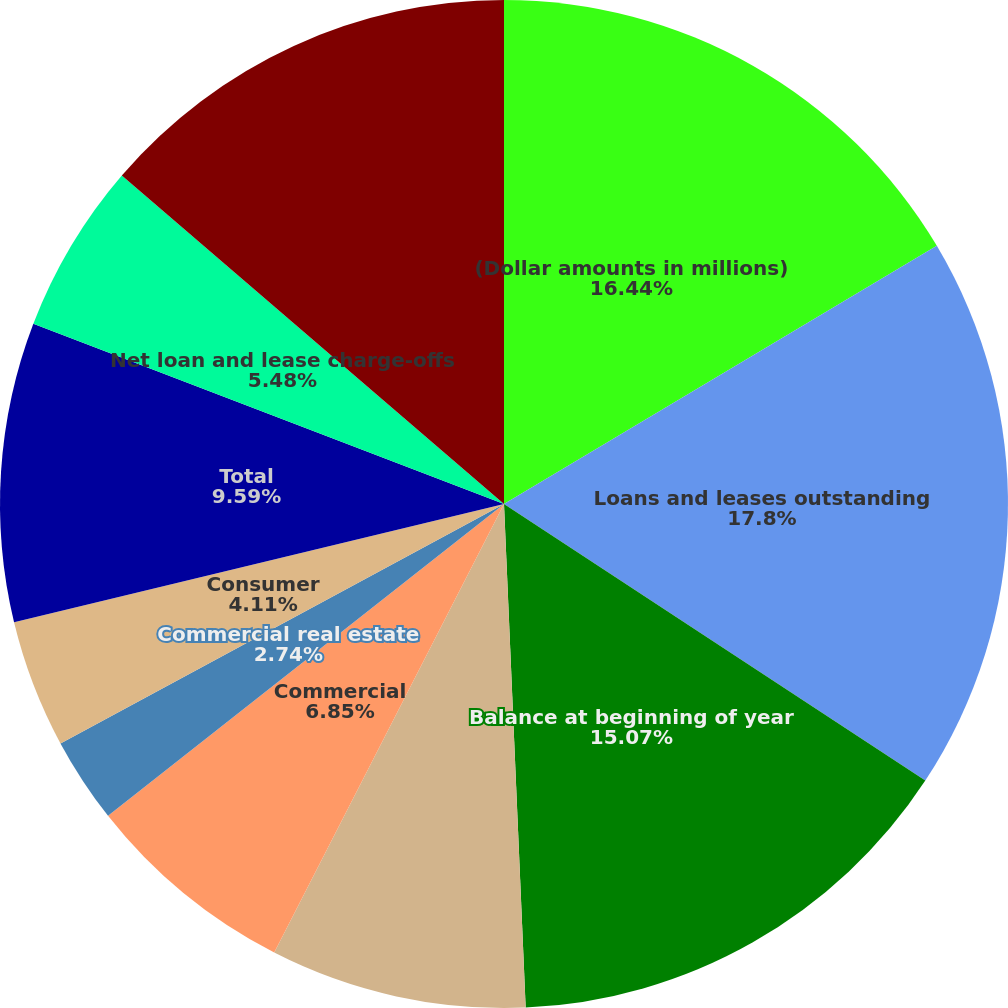Convert chart. <chart><loc_0><loc_0><loc_500><loc_500><pie_chart><fcel>(Dollar amounts in millions)<fcel>Loans and leases outstanding<fcel>Balance at beginning of year<fcel>Provision charged to earnings<fcel>Commercial<fcel>Commercial real estate<fcel>Consumer<fcel>Total<fcel>Net loan and lease charge-offs<fcel>Balance at end of year<nl><fcel>16.44%<fcel>17.81%<fcel>15.07%<fcel>8.22%<fcel>6.85%<fcel>2.74%<fcel>4.11%<fcel>9.59%<fcel>5.48%<fcel>13.7%<nl></chart> 